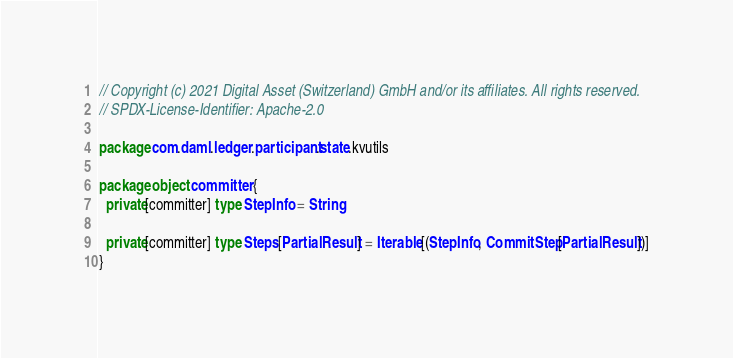Convert code to text. <code><loc_0><loc_0><loc_500><loc_500><_Scala_>// Copyright (c) 2021 Digital Asset (Switzerland) GmbH and/or its affiliates. All rights reserved.
// SPDX-License-Identifier: Apache-2.0

package com.daml.ledger.participant.state.kvutils

package object committer {
  private[committer] type StepInfo = String

  private[committer] type Steps[PartialResult] = Iterable[(StepInfo, CommitStep[PartialResult])]
}
</code> 